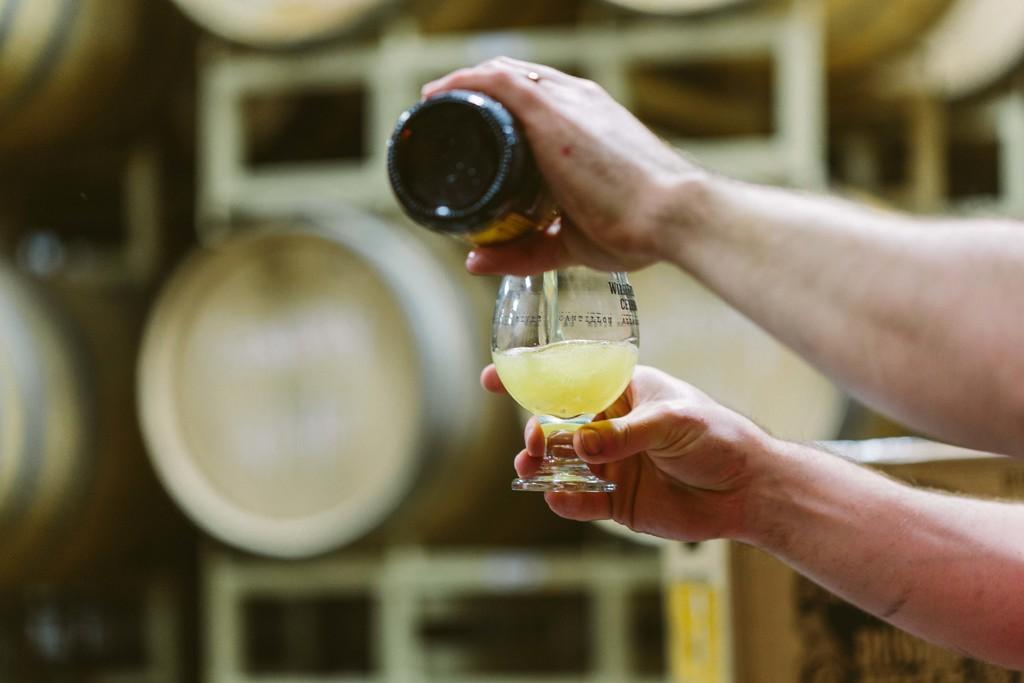What can be seen in the image involving human hands? There are two human hands in the image, and they are holding a glass. What action are the hands performing with the glass? The hands are pouring a drink into the glass. Can you describe the background of the image? The background of the image is blurred. Did the earthquake cause the glass to fall off the table in the image? There is no earthquake or table present in the image, and the glass is being held by the hands. Is there a train visible in the background of the image? There is no train present in the image; the background is blurred. 